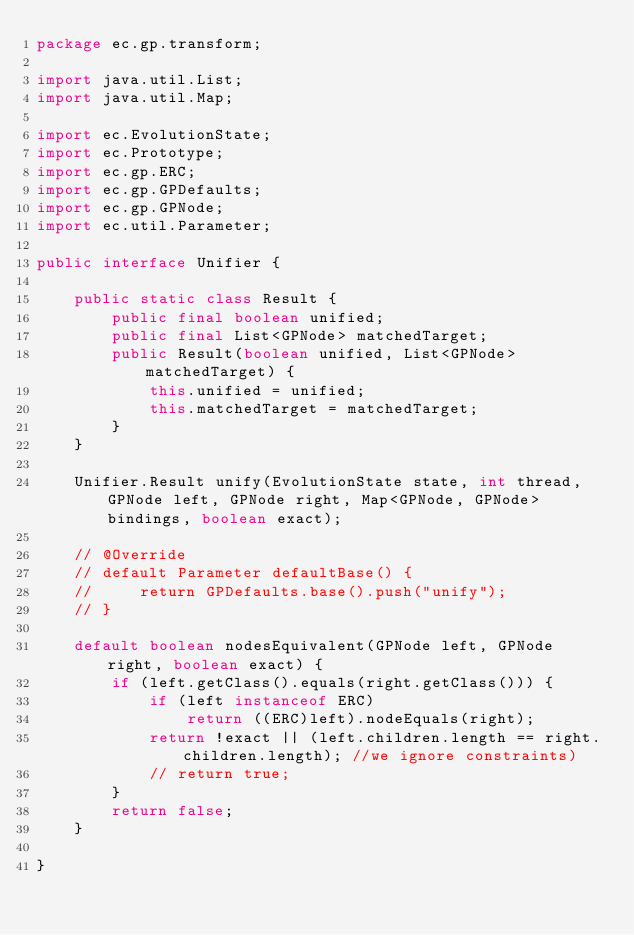Convert code to text. <code><loc_0><loc_0><loc_500><loc_500><_Java_>package ec.gp.transform;

import java.util.List;
import java.util.Map;

import ec.EvolutionState;
import ec.Prototype;
import ec.gp.ERC;
import ec.gp.GPDefaults;
import ec.gp.GPNode;
import ec.util.Parameter;

public interface Unifier {

    public static class Result {
        public final boolean unified; 
        public final List<GPNode> matchedTarget;
        public Result(boolean unified, List<GPNode> matchedTarget) {
            this.unified = unified;
            this.matchedTarget = matchedTarget;
        }
    }

    Unifier.Result unify(EvolutionState state, int thread, GPNode left, GPNode right, Map<GPNode, GPNode> bindings, boolean exact);  

    // @Override
    // default Parameter defaultBase() {
    //     return GPDefaults.base().push("unify");
    // }

    default boolean nodesEquivalent(GPNode left, GPNode right, boolean exact) {
        if (left.getClass().equals(right.getClass())) {
            if (left instanceof ERC)
                return ((ERC)left).nodeEquals(right);
            return !exact || (left.children.length == right.children.length); //we ignore constraints)
            // return true;
        }
        return false;
    }     

}
</code> 